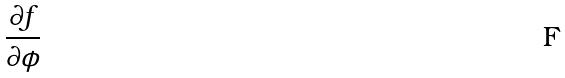<formula> <loc_0><loc_0><loc_500><loc_500>\frac { \partial f } { \partial \phi }</formula> 